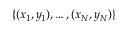Convert formula to latex. <formula><loc_0><loc_0><loc_500><loc_500>\{ ( x _ { 1 } , y _ { 1 } ) , \dots , ( x _ { N } , y _ { N } ) \}</formula> 